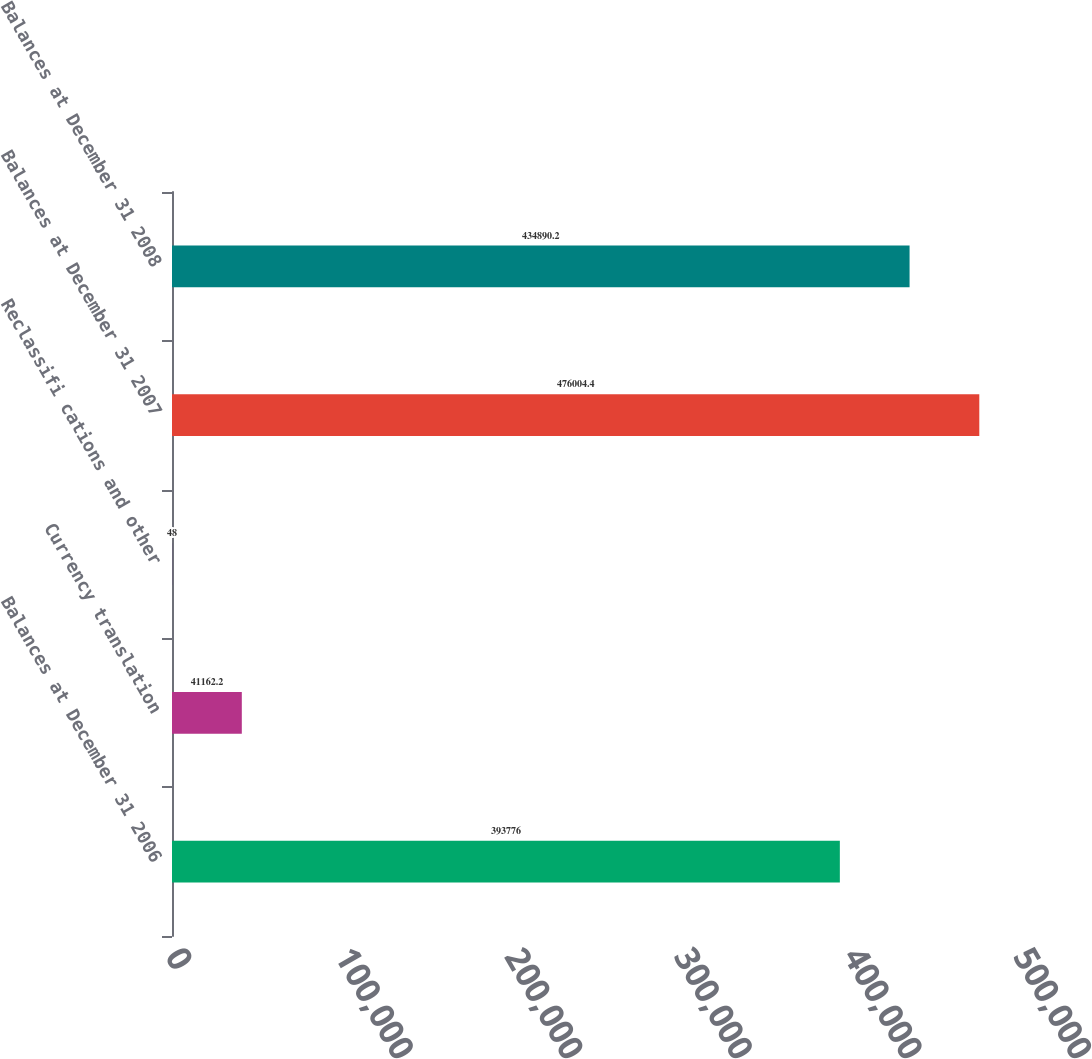Convert chart. <chart><loc_0><loc_0><loc_500><loc_500><bar_chart><fcel>Balances at December 31 2006<fcel>Currency translation<fcel>Reclassifi cations and other<fcel>Balances at December 31 2007<fcel>Balances at December 31 2008<nl><fcel>393776<fcel>41162.2<fcel>48<fcel>476004<fcel>434890<nl></chart> 